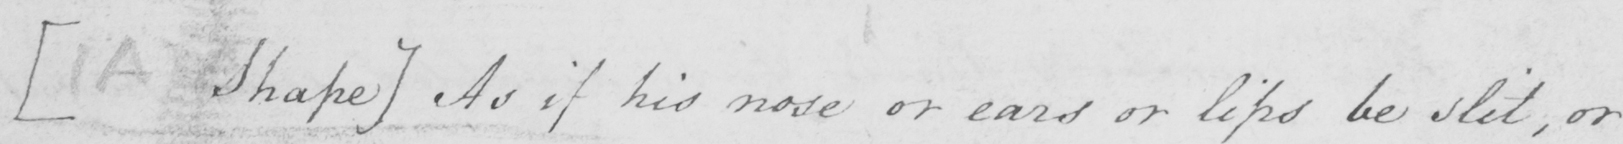What text is written in this handwritten line? [A Shape] As if his nose or ears or lips be split, or 